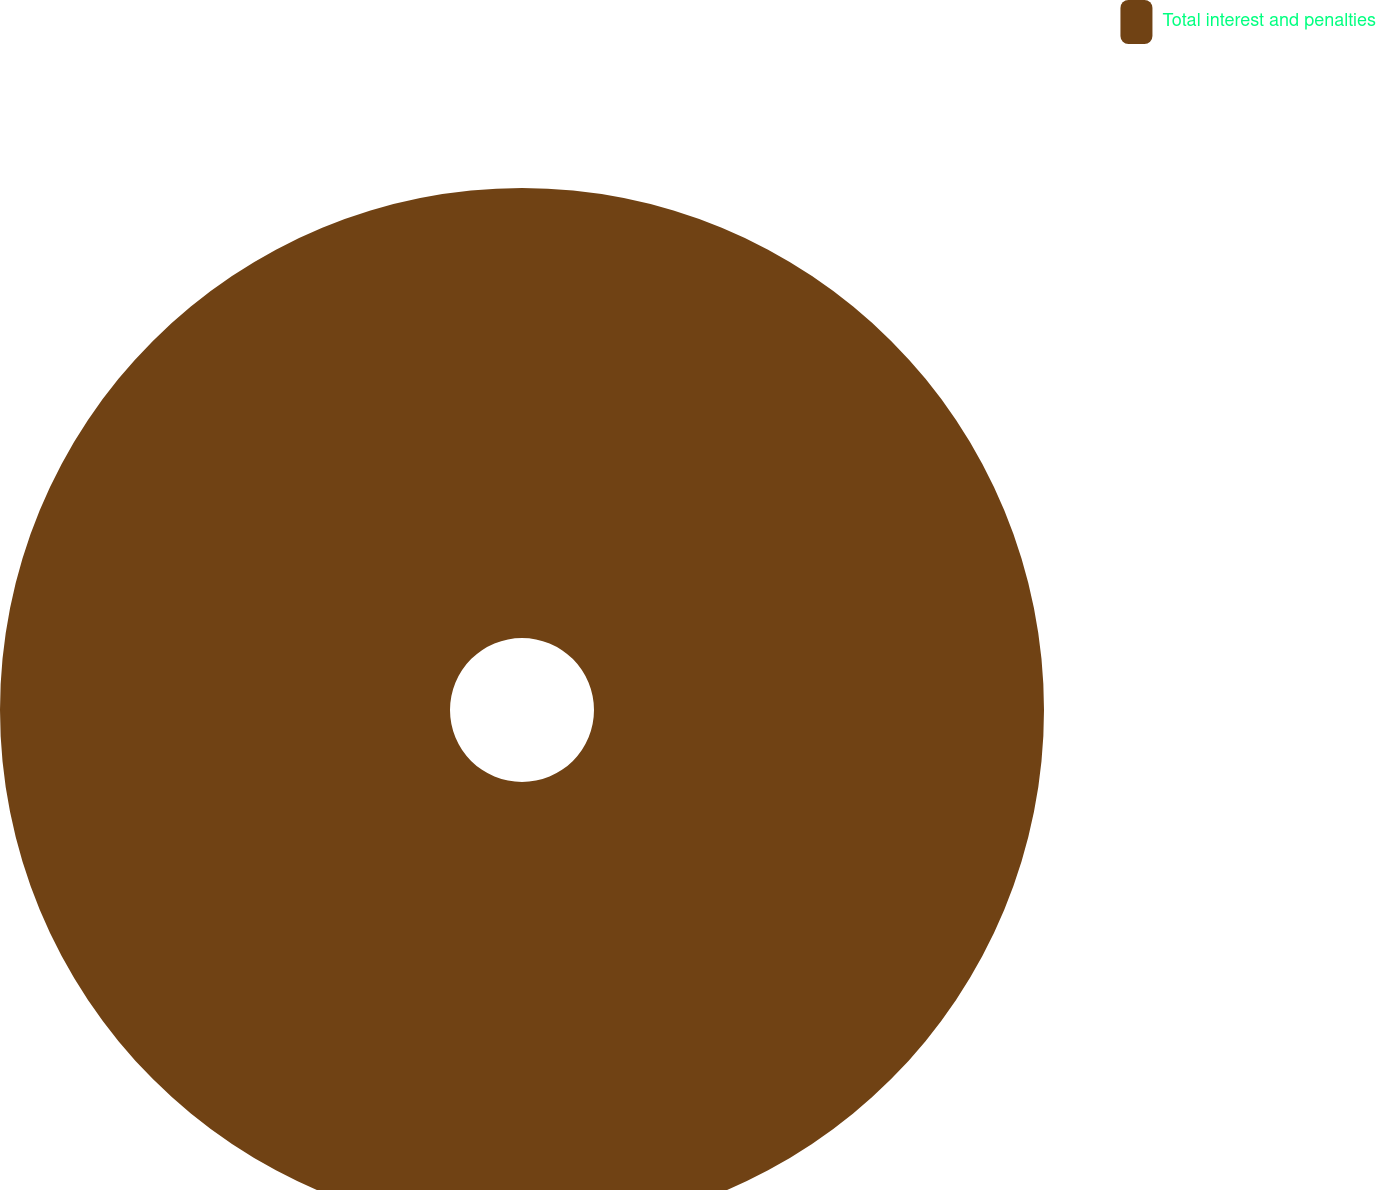Convert chart to OTSL. <chart><loc_0><loc_0><loc_500><loc_500><pie_chart><fcel>Total interest and penalties<nl><fcel>100.0%<nl></chart> 